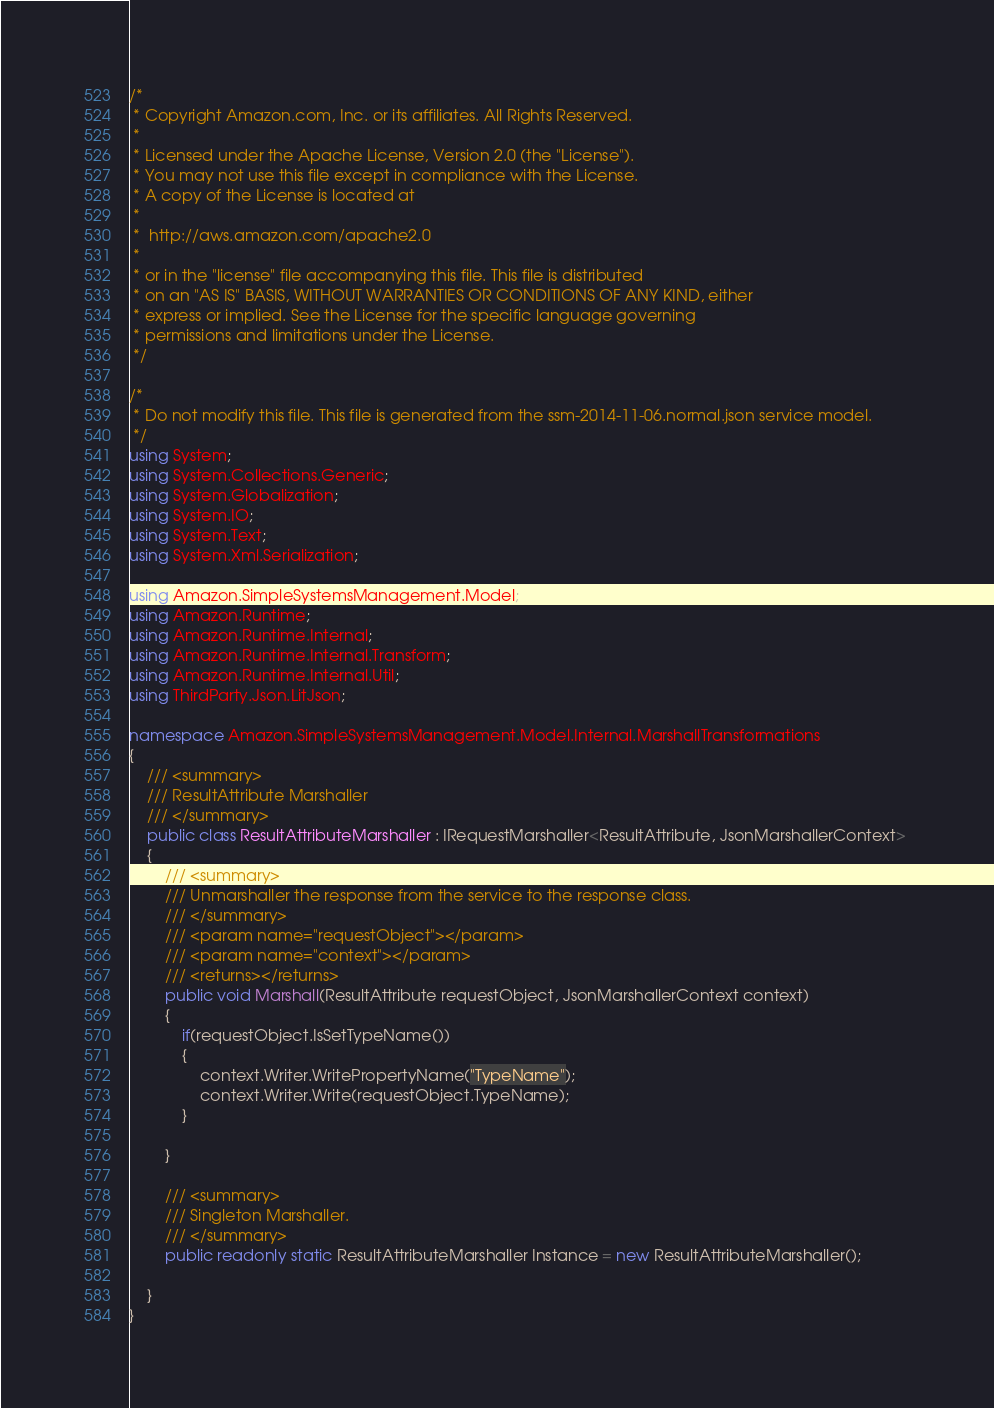<code> <loc_0><loc_0><loc_500><loc_500><_C#_>/*
 * Copyright Amazon.com, Inc. or its affiliates. All Rights Reserved.
 * 
 * Licensed under the Apache License, Version 2.0 (the "License").
 * You may not use this file except in compliance with the License.
 * A copy of the License is located at
 * 
 *  http://aws.amazon.com/apache2.0
 * 
 * or in the "license" file accompanying this file. This file is distributed
 * on an "AS IS" BASIS, WITHOUT WARRANTIES OR CONDITIONS OF ANY KIND, either
 * express or implied. See the License for the specific language governing
 * permissions and limitations under the License.
 */

/*
 * Do not modify this file. This file is generated from the ssm-2014-11-06.normal.json service model.
 */
using System;
using System.Collections.Generic;
using System.Globalization;
using System.IO;
using System.Text;
using System.Xml.Serialization;

using Amazon.SimpleSystemsManagement.Model;
using Amazon.Runtime;
using Amazon.Runtime.Internal;
using Amazon.Runtime.Internal.Transform;
using Amazon.Runtime.Internal.Util;
using ThirdParty.Json.LitJson;

namespace Amazon.SimpleSystemsManagement.Model.Internal.MarshallTransformations
{
    /// <summary>
    /// ResultAttribute Marshaller
    /// </summary>       
    public class ResultAttributeMarshaller : IRequestMarshaller<ResultAttribute, JsonMarshallerContext> 
    {
        /// <summary>
        /// Unmarshaller the response from the service to the response class.
        /// </summary>  
        /// <param name="requestObject"></param>
        /// <param name="context"></param>
        /// <returns></returns>
        public void Marshall(ResultAttribute requestObject, JsonMarshallerContext context)
        {
            if(requestObject.IsSetTypeName())
            {
                context.Writer.WritePropertyName("TypeName");
                context.Writer.Write(requestObject.TypeName);
            }

        }

        /// <summary>
        /// Singleton Marshaller.
        /// </summary>  
        public readonly static ResultAttributeMarshaller Instance = new ResultAttributeMarshaller();

    }
}</code> 